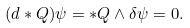<formula> <loc_0><loc_0><loc_500><loc_500>( d * Q ) \psi = * Q \wedge \delta \psi = 0 .</formula> 